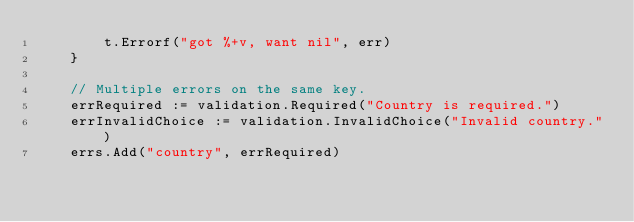<code> <loc_0><loc_0><loc_500><loc_500><_Go_>		t.Errorf("got %+v, want nil", err)
	}

	// Multiple errors on the same key.
	errRequired := validation.Required("Country is required.")
	errInvalidChoice := validation.InvalidChoice("Invalid country.")
	errs.Add("country", errRequired)</code> 